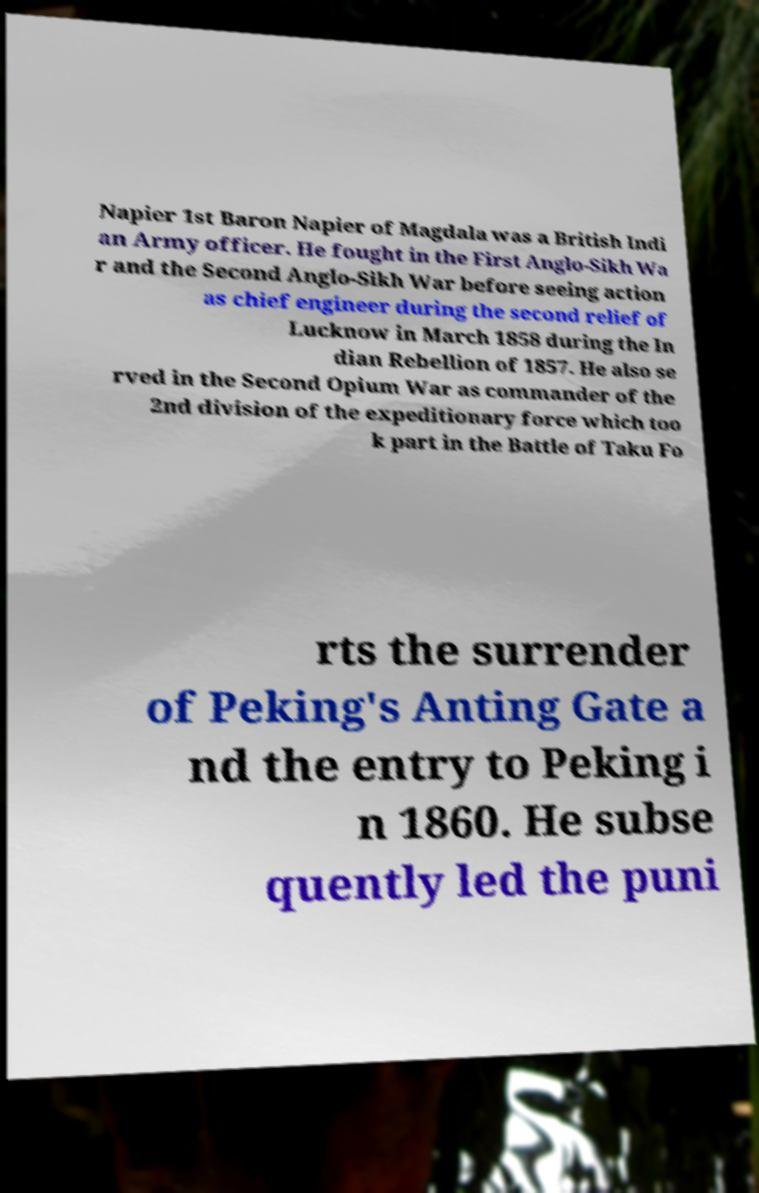What messages or text are displayed in this image? I need them in a readable, typed format. Napier 1st Baron Napier of Magdala was a British Indi an Army officer. He fought in the First Anglo-Sikh Wa r and the Second Anglo-Sikh War before seeing action as chief engineer during the second relief of Lucknow in March 1858 during the In dian Rebellion of 1857. He also se rved in the Second Opium War as commander of the 2nd division of the expeditionary force which too k part in the Battle of Taku Fo rts the surrender of Peking's Anting Gate a nd the entry to Peking i n 1860. He subse quently led the puni 